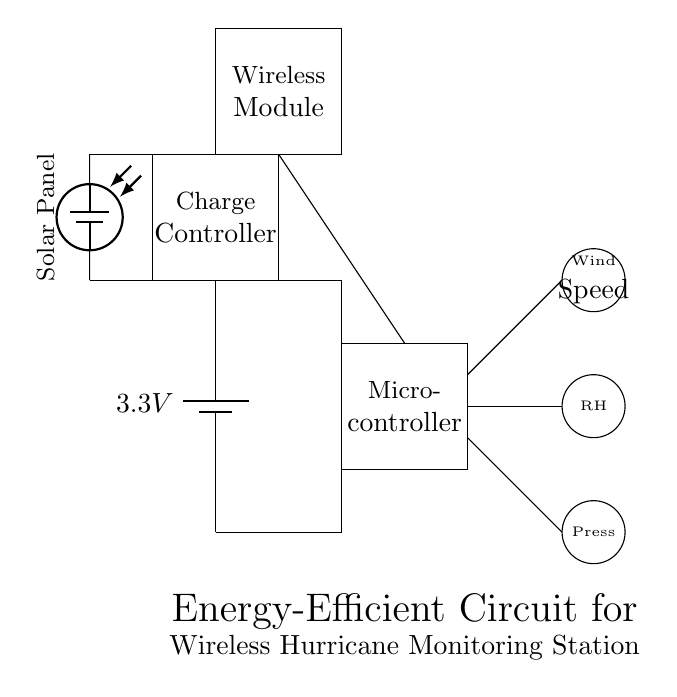What is the voltage of the power source? The power source is a battery indicated to provide 3.3V, shown within the circuit as a labeled battery symbol.
Answer: 3.3V What components are used for weather monitoring? The circuit contains three sensors: a wind speed sensor, a humidity sensor, and a pressure sensor, each represented by different symbols in the layout.
Answer: Wind speed sensor, humidity sensor, pressure sensor What is the function of the charge controller? The charge controller manages the power from the solar panel to the battery, ensuring efficient charging and prolonging battery life; it's depicted as a rectangular box labeled in the circuit.
Answer: Power management How is the microcontroller connected in the circuit? The microcontroller is connected to the wireless module and the three sensors, facilitating the processing of data and communication; this is visualized through lines leading from these components.
Answer: Connected to sensors and wireless module What is the role of the solar panel in this circuit? The solar panel converts solar energy into electrical energy, which is stored in the battery via the charge controller, ensuring the system operates independently of the grid.
Answer: Energy source How does the wireless module contribute to the monitoring system? The wireless module allows the system to transmit collected data from the sensors to a remote location for analysis; its placement connects to the microcontroller.
Answer: Data transmission 